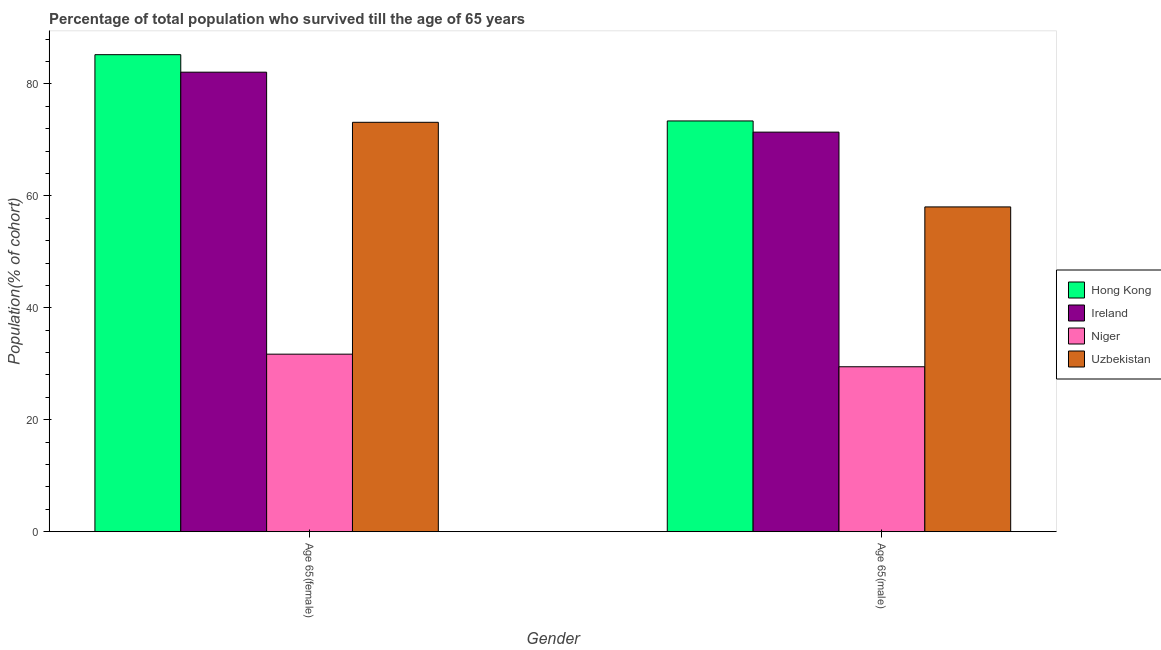How many different coloured bars are there?
Give a very brief answer. 4. How many groups of bars are there?
Your answer should be very brief. 2. What is the label of the 1st group of bars from the left?
Your response must be concise. Age 65(female). What is the percentage of female population who survived till age of 65 in Hong Kong?
Offer a terse response. 85.22. Across all countries, what is the maximum percentage of male population who survived till age of 65?
Ensure brevity in your answer.  73.38. Across all countries, what is the minimum percentage of female population who survived till age of 65?
Your response must be concise. 31.72. In which country was the percentage of male population who survived till age of 65 maximum?
Provide a succinct answer. Hong Kong. In which country was the percentage of female population who survived till age of 65 minimum?
Your response must be concise. Niger. What is the total percentage of female population who survived till age of 65 in the graph?
Your response must be concise. 272.17. What is the difference between the percentage of female population who survived till age of 65 in Niger and that in Hong Kong?
Make the answer very short. -53.5. What is the difference between the percentage of female population who survived till age of 65 in Uzbekistan and the percentage of male population who survived till age of 65 in Hong Kong?
Keep it short and to the point. -0.24. What is the average percentage of male population who survived till age of 65 per country?
Your response must be concise. 58.06. What is the difference between the percentage of male population who survived till age of 65 and percentage of female population who survived till age of 65 in Niger?
Make the answer very short. -2.25. What is the ratio of the percentage of female population who survived till age of 65 in Uzbekistan to that in Ireland?
Offer a very short reply. 0.89. In how many countries, is the percentage of male population who survived till age of 65 greater than the average percentage of male population who survived till age of 65 taken over all countries?
Keep it short and to the point. 2. What does the 4th bar from the left in Age 65(female) represents?
Your answer should be compact. Uzbekistan. What does the 4th bar from the right in Age 65(female) represents?
Provide a succinct answer. Hong Kong. Are all the bars in the graph horizontal?
Offer a terse response. No. How many countries are there in the graph?
Ensure brevity in your answer.  4. What is the difference between two consecutive major ticks on the Y-axis?
Your response must be concise. 20. Does the graph contain any zero values?
Ensure brevity in your answer.  No. How are the legend labels stacked?
Offer a terse response. Vertical. What is the title of the graph?
Your answer should be compact. Percentage of total population who survived till the age of 65 years. What is the label or title of the X-axis?
Your answer should be compact. Gender. What is the label or title of the Y-axis?
Your answer should be very brief. Population(% of cohort). What is the Population(% of cohort) of Hong Kong in Age 65(female)?
Ensure brevity in your answer.  85.22. What is the Population(% of cohort) in Ireland in Age 65(female)?
Offer a terse response. 82.09. What is the Population(% of cohort) in Niger in Age 65(female)?
Provide a succinct answer. 31.72. What is the Population(% of cohort) in Uzbekistan in Age 65(female)?
Your answer should be compact. 73.14. What is the Population(% of cohort) in Hong Kong in Age 65(male)?
Your response must be concise. 73.38. What is the Population(% of cohort) of Ireland in Age 65(male)?
Provide a short and direct response. 71.38. What is the Population(% of cohort) of Niger in Age 65(male)?
Keep it short and to the point. 29.47. What is the Population(% of cohort) of Uzbekistan in Age 65(male)?
Provide a short and direct response. 58.02. Across all Gender, what is the maximum Population(% of cohort) of Hong Kong?
Ensure brevity in your answer.  85.22. Across all Gender, what is the maximum Population(% of cohort) in Ireland?
Make the answer very short. 82.09. Across all Gender, what is the maximum Population(% of cohort) of Niger?
Provide a succinct answer. 31.72. Across all Gender, what is the maximum Population(% of cohort) of Uzbekistan?
Give a very brief answer. 73.14. Across all Gender, what is the minimum Population(% of cohort) of Hong Kong?
Your answer should be compact. 73.38. Across all Gender, what is the minimum Population(% of cohort) of Ireland?
Give a very brief answer. 71.38. Across all Gender, what is the minimum Population(% of cohort) in Niger?
Offer a terse response. 29.47. Across all Gender, what is the minimum Population(% of cohort) in Uzbekistan?
Provide a short and direct response. 58.02. What is the total Population(% of cohort) of Hong Kong in the graph?
Provide a short and direct response. 158.6. What is the total Population(% of cohort) in Ireland in the graph?
Offer a very short reply. 153.48. What is the total Population(% of cohort) of Niger in the graph?
Your answer should be compact. 61.19. What is the total Population(% of cohort) in Uzbekistan in the graph?
Provide a short and direct response. 131.16. What is the difference between the Population(% of cohort) in Hong Kong in Age 65(female) and that in Age 65(male)?
Your answer should be very brief. 11.84. What is the difference between the Population(% of cohort) of Ireland in Age 65(female) and that in Age 65(male)?
Keep it short and to the point. 10.71. What is the difference between the Population(% of cohort) in Niger in Age 65(female) and that in Age 65(male)?
Make the answer very short. 2.25. What is the difference between the Population(% of cohort) in Uzbekistan in Age 65(female) and that in Age 65(male)?
Provide a short and direct response. 15.12. What is the difference between the Population(% of cohort) of Hong Kong in Age 65(female) and the Population(% of cohort) of Ireland in Age 65(male)?
Your answer should be compact. 13.84. What is the difference between the Population(% of cohort) in Hong Kong in Age 65(female) and the Population(% of cohort) in Niger in Age 65(male)?
Your answer should be very brief. 55.75. What is the difference between the Population(% of cohort) of Hong Kong in Age 65(female) and the Population(% of cohort) of Uzbekistan in Age 65(male)?
Your answer should be compact. 27.2. What is the difference between the Population(% of cohort) of Ireland in Age 65(female) and the Population(% of cohort) of Niger in Age 65(male)?
Provide a short and direct response. 52.63. What is the difference between the Population(% of cohort) of Ireland in Age 65(female) and the Population(% of cohort) of Uzbekistan in Age 65(male)?
Offer a very short reply. 24.07. What is the difference between the Population(% of cohort) in Niger in Age 65(female) and the Population(% of cohort) in Uzbekistan in Age 65(male)?
Keep it short and to the point. -26.31. What is the average Population(% of cohort) in Hong Kong per Gender?
Offer a very short reply. 79.3. What is the average Population(% of cohort) in Ireland per Gender?
Your answer should be very brief. 76.74. What is the average Population(% of cohort) of Niger per Gender?
Give a very brief answer. 30.59. What is the average Population(% of cohort) of Uzbekistan per Gender?
Ensure brevity in your answer.  65.58. What is the difference between the Population(% of cohort) in Hong Kong and Population(% of cohort) in Ireland in Age 65(female)?
Keep it short and to the point. 3.13. What is the difference between the Population(% of cohort) of Hong Kong and Population(% of cohort) of Niger in Age 65(female)?
Give a very brief answer. 53.5. What is the difference between the Population(% of cohort) in Hong Kong and Population(% of cohort) in Uzbekistan in Age 65(female)?
Offer a terse response. 12.08. What is the difference between the Population(% of cohort) in Ireland and Population(% of cohort) in Niger in Age 65(female)?
Provide a succinct answer. 50.38. What is the difference between the Population(% of cohort) of Ireland and Population(% of cohort) of Uzbekistan in Age 65(female)?
Keep it short and to the point. 8.95. What is the difference between the Population(% of cohort) of Niger and Population(% of cohort) of Uzbekistan in Age 65(female)?
Your answer should be compact. -41.42. What is the difference between the Population(% of cohort) of Hong Kong and Population(% of cohort) of Niger in Age 65(male)?
Provide a succinct answer. 43.92. What is the difference between the Population(% of cohort) in Hong Kong and Population(% of cohort) in Uzbekistan in Age 65(male)?
Your answer should be compact. 15.36. What is the difference between the Population(% of cohort) of Ireland and Population(% of cohort) of Niger in Age 65(male)?
Make the answer very short. 41.92. What is the difference between the Population(% of cohort) in Ireland and Population(% of cohort) in Uzbekistan in Age 65(male)?
Ensure brevity in your answer.  13.36. What is the difference between the Population(% of cohort) of Niger and Population(% of cohort) of Uzbekistan in Age 65(male)?
Provide a short and direct response. -28.56. What is the ratio of the Population(% of cohort) in Hong Kong in Age 65(female) to that in Age 65(male)?
Give a very brief answer. 1.16. What is the ratio of the Population(% of cohort) in Ireland in Age 65(female) to that in Age 65(male)?
Offer a terse response. 1.15. What is the ratio of the Population(% of cohort) of Niger in Age 65(female) to that in Age 65(male)?
Give a very brief answer. 1.08. What is the ratio of the Population(% of cohort) of Uzbekistan in Age 65(female) to that in Age 65(male)?
Provide a succinct answer. 1.26. What is the difference between the highest and the second highest Population(% of cohort) of Hong Kong?
Provide a short and direct response. 11.84. What is the difference between the highest and the second highest Population(% of cohort) of Ireland?
Offer a very short reply. 10.71. What is the difference between the highest and the second highest Population(% of cohort) of Niger?
Your response must be concise. 2.25. What is the difference between the highest and the second highest Population(% of cohort) in Uzbekistan?
Your answer should be compact. 15.12. What is the difference between the highest and the lowest Population(% of cohort) in Hong Kong?
Your response must be concise. 11.84. What is the difference between the highest and the lowest Population(% of cohort) of Ireland?
Your answer should be very brief. 10.71. What is the difference between the highest and the lowest Population(% of cohort) of Niger?
Your response must be concise. 2.25. What is the difference between the highest and the lowest Population(% of cohort) of Uzbekistan?
Offer a very short reply. 15.12. 